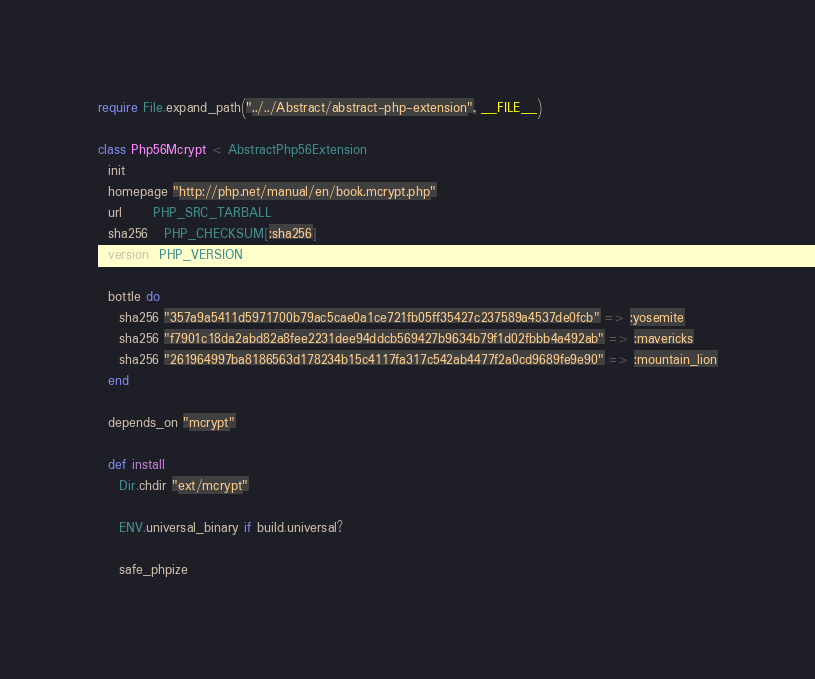Convert code to text. <code><loc_0><loc_0><loc_500><loc_500><_Ruby_>require File.expand_path("../../Abstract/abstract-php-extension", __FILE__)

class Php56Mcrypt < AbstractPhp56Extension
  init
  homepage "http://php.net/manual/en/book.mcrypt.php"
  url      PHP_SRC_TARBALL
  sha256   PHP_CHECKSUM[:sha256]
  version  PHP_VERSION

  bottle do
    sha256 "357a9a5411d5971700b79ac5cae0a1ce721fb05ff35427c237589a4537de0fcb" => :yosemite
    sha256 "f7901c18da2abd82a8fee2231dee94ddcb569427b9634b79f1d02fbbb4a492ab" => :mavericks
    sha256 "261964997ba8186563d178234b15c4117fa317c542ab4477f2a0cd9689fe9e90" => :mountain_lion
  end

  depends_on "mcrypt"

  def install
    Dir.chdir "ext/mcrypt"

    ENV.universal_binary if build.universal?

    safe_phpize</code> 